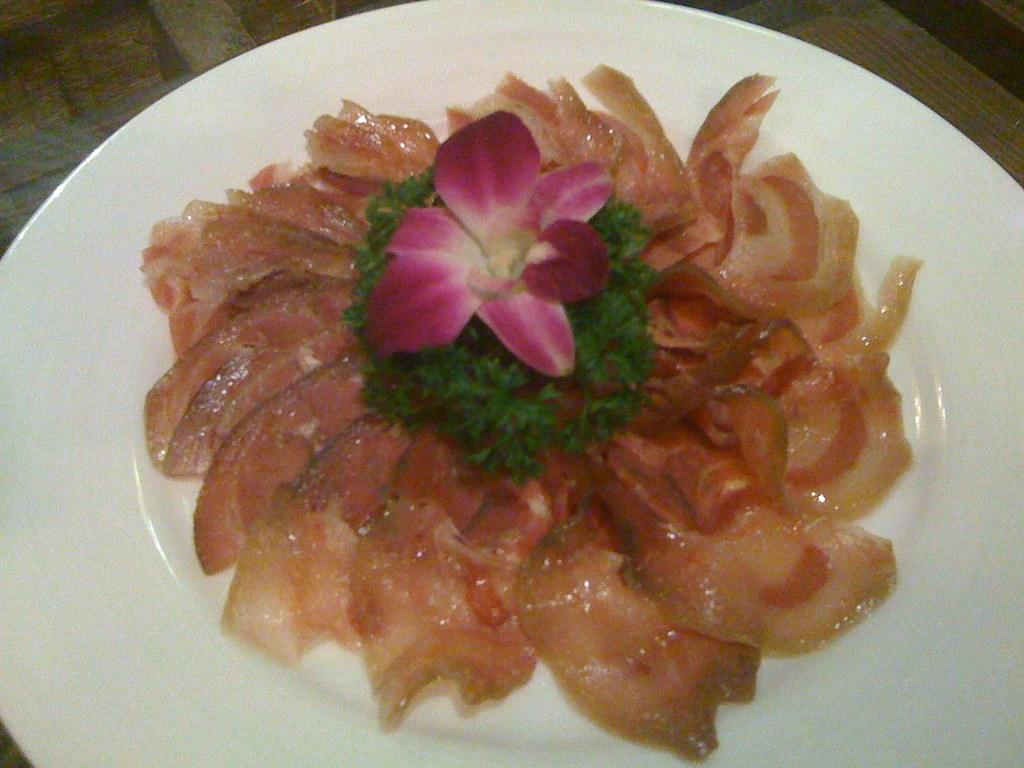What is the main subject of the image? There is a food item on a plate in the image. What type of pet can be seen reading a story in the image? There is no pet or story present in the image; it only features a food item on a plate. 